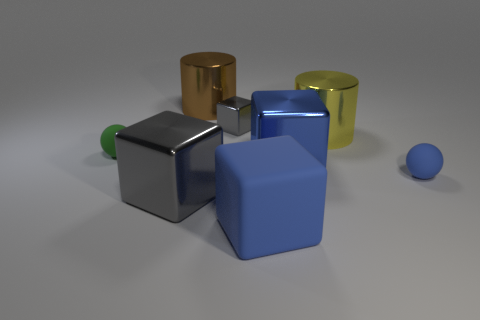Which object stands out the most and why? The gold-colored cylinder stands out the most due to its reflective surface and distinct color that contrasts with the other objects. 